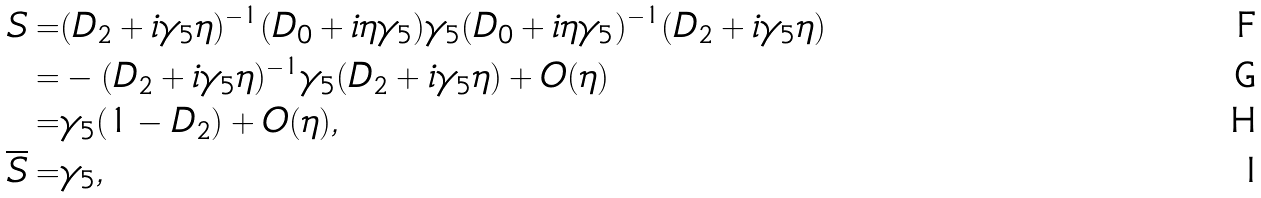<formula> <loc_0><loc_0><loc_500><loc_500>S = & ( D _ { 2 } + i \gamma _ { 5 } \eta ) ^ { - 1 } ( D _ { 0 } + i \eta \gamma _ { 5 } ) \gamma _ { 5 } ( D _ { 0 } + i \eta \gamma _ { 5 } ) ^ { - 1 } ( D _ { 2 } + i \gamma _ { 5 } \eta ) \\ = & - ( D _ { 2 } + i \gamma _ { 5 } \eta ) ^ { - 1 } \gamma _ { 5 } ( D _ { 2 } + i \gamma _ { 5 } \eta ) + O ( \eta ) \\ = & \gamma _ { 5 } ( 1 - D _ { 2 } ) + O ( \eta ) , \\ \overline { S } = & \gamma _ { 5 } ,</formula> 